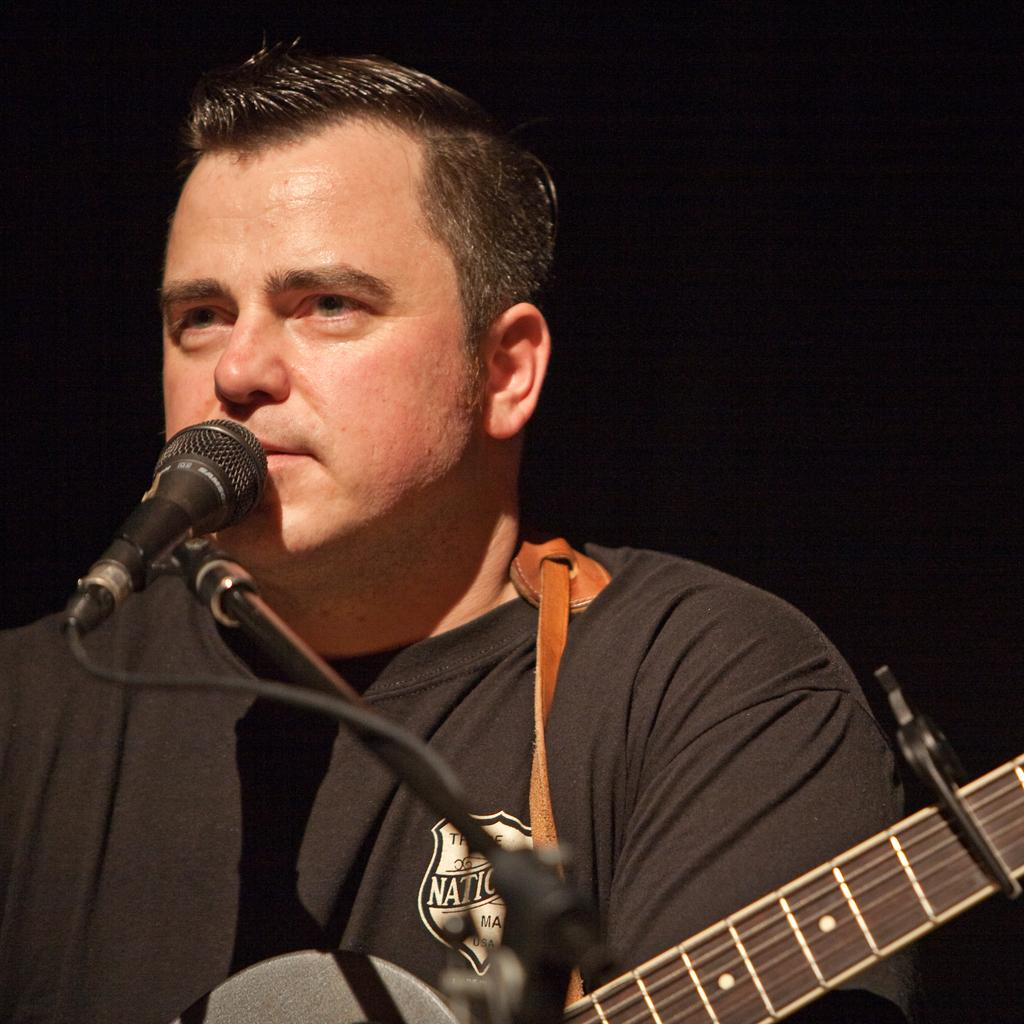What is the main subject of the image? There is a person in the image. What is the person doing in the image? The person is playing a guitar. What object is in front of the person? There is a microphone in front of the person. What type of caption is written on the guitar in the image? There is no caption written on the guitar in the image. How many oranges are visible on the person's head in the image? There are no oranges present in the image. 